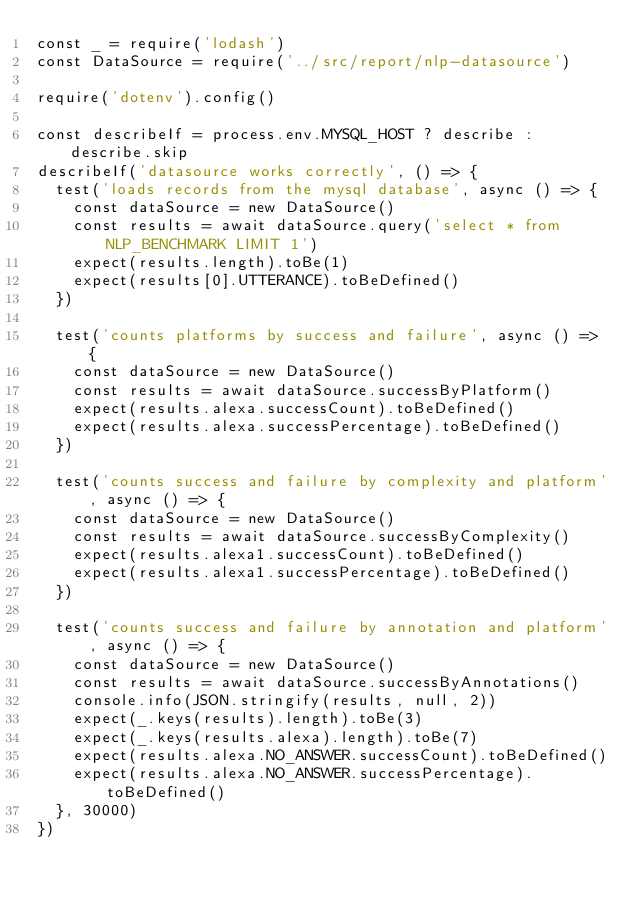Convert code to text. <code><loc_0><loc_0><loc_500><loc_500><_JavaScript_>const _ = require('lodash')
const DataSource = require('../src/report/nlp-datasource')

require('dotenv').config()

const describeIf = process.env.MYSQL_HOST ? describe : describe.skip
describeIf('datasource works correctly', () => {
  test('loads records from the mysql database', async () => {
    const dataSource = new DataSource()
    const results = await dataSource.query('select * from NLP_BENCHMARK LIMIT 1')
    expect(results.length).toBe(1)
    expect(results[0].UTTERANCE).toBeDefined()
  })

  test('counts platforms by success and failure', async () => {
    const dataSource = new DataSource()
    const results = await dataSource.successByPlatform()
    expect(results.alexa.successCount).toBeDefined()
    expect(results.alexa.successPercentage).toBeDefined()
  })

  test('counts success and failure by complexity and platform', async () => {
    const dataSource = new DataSource()
    const results = await dataSource.successByComplexity()
    expect(results.alexa1.successCount).toBeDefined()
    expect(results.alexa1.successPercentage).toBeDefined()
  })

  test('counts success and failure by annotation and platform', async () => {
    const dataSource = new DataSource()
    const results = await dataSource.successByAnnotations()
    console.info(JSON.stringify(results, null, 2))
    expect(_.keys(results).length).toBe(3)
    expect(_.keys(results.alexa).length).toBe(7)
    expect(results.alexa.NO_ANSWER.successCount).toBeDefined()
    expect(results.alexa.NO_ANSWER.successPercentage).toBeDefined()
  }, 30000)
})
</code> 